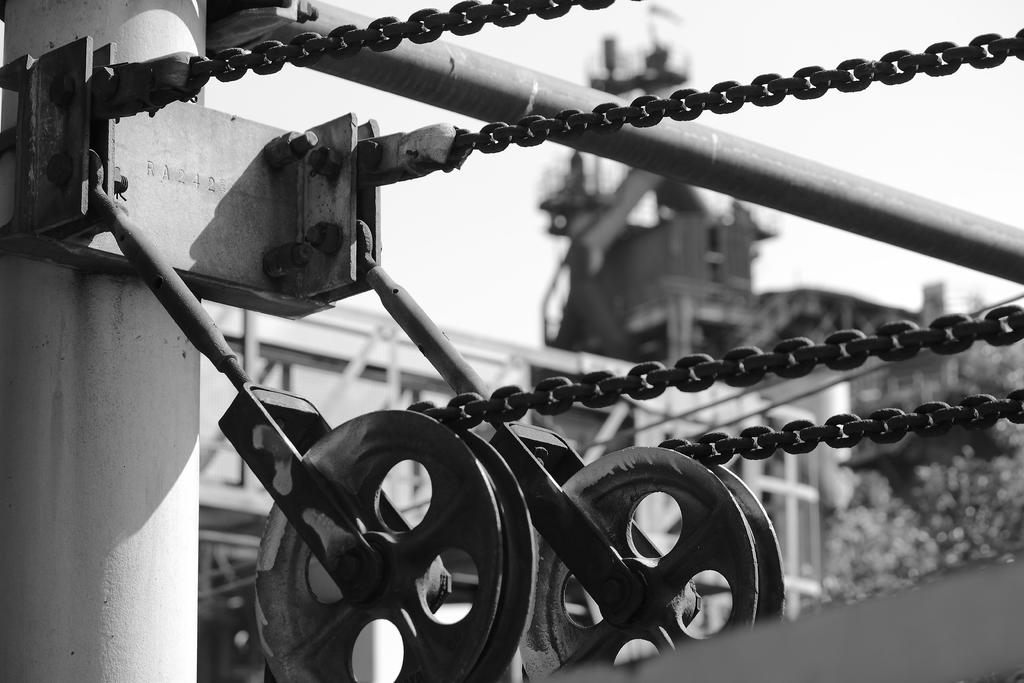What objects are in the foreground of the image? In the foreground of the image, there are metal chains, wheels, and metal pipes. What can be seen in the background of the image? In the background of the image, there are buildings, trees, plants, and the sky. Can you describe the time of day when the image was taken? The image was likely taken during the day, as the sky is visible and not dark. What is the texture of the jelly in the image? There is no jelly present in the image, so it is not possible to determine its texture. 